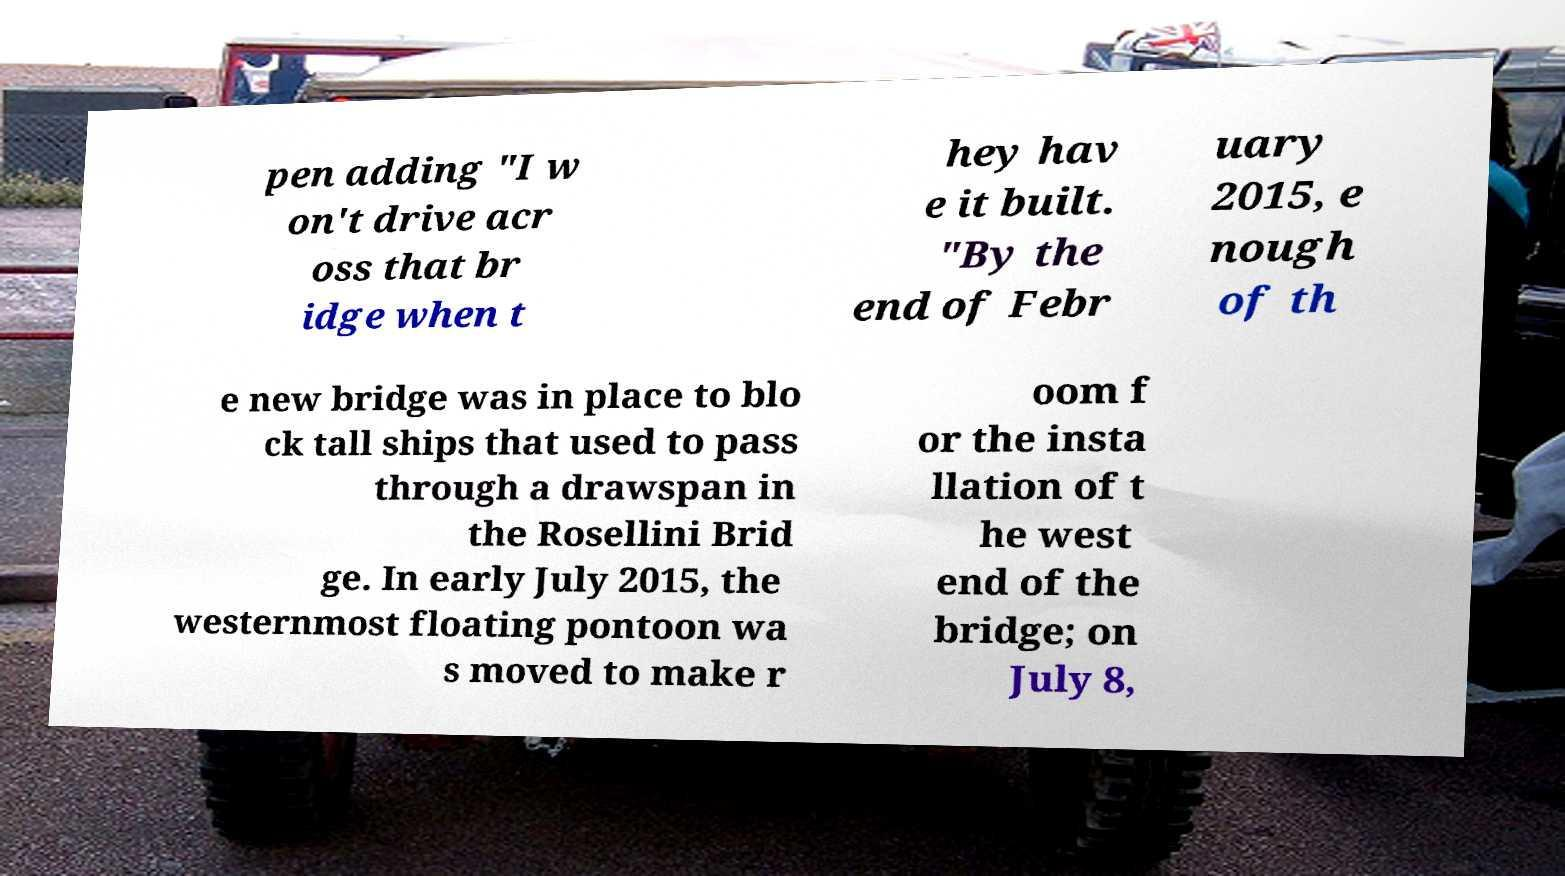Please read and relay the text visible in this image. What does it say? pen adding "I w on't drive acr oss that br idge when t hey hav e it built. "By the end of Febr uary 2015, e nough of th e new bridge was in place to blo ck tall ships that used to pass through a drawspan in the Rosellini Brid ge. In early July 2015, the westernmost floating pontoon wa s moved to make r oom f or the insta llation of t he west end of the bridge; on July 8, 